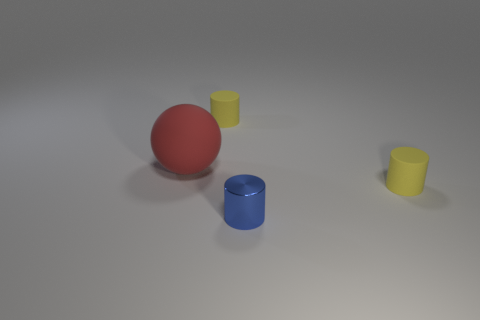The tiny yellow cylinder to the right of the small rubber thing to the left of the blue metal object that is in front of the red matte object is made of what material?
Give a very brief answer. Rubber. What number of big objects are either red balls or green metallic cubes?
Keep it short and to the point. 1. What number of other objects are the same size as the rubber ball?
Offer a terse response. 0. There is a small rubber thing that is to the right of the tiny blue shiny cylinder; does it have the same shape as the red object?
Your answer should be very brief. No. Is there anything else that is the same shape as the red rubber object?
Make the answer very short. No. Are there the same number of blue objects that are to the right of the blue shiny cylinder and small objects?
Keep it short and to the point. No. What number of yellow cylinders are both in front of the big red rubber ball and behind the large matte object?
Offer a very short reply. 0. What number of large things have the same material as the large ball?
Provide a succinct answer. 0. Are there fewer small blue cylinders behind the metallic object than small metal cylinders?
Your answer should be compact. Yes. What number of red matte spheres are there?
Ensure brevity in your answer.  1. 